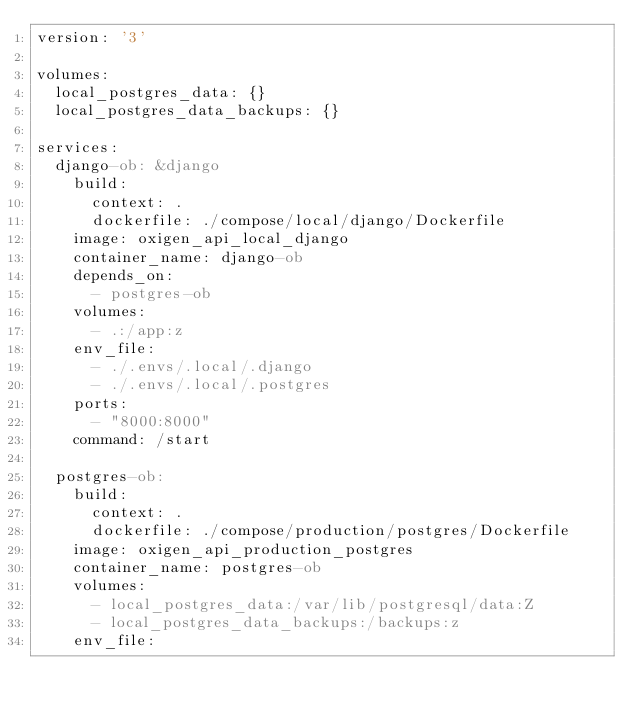Convert code to text. <code><loc_0><loc_0><loc_500><loc_500><_YAML_>version: '3'

volumes:
  local_postgres_data: {}
  local_postgres_data_backups: {}

services:
  django-ob: &django
    build:
      context: .
      dockerfile: ./compose/local/django/Dockerfile
    image: oxigen_api_local_django
    container_name: django-ob
    depends_on:
      - postgres-ob
    volumes:
      - .:/app:z
    env_file:
      - ./.envs/.local/.django
      - ./.envs/.local/.postgres
    ports:
      - "8000:8000"
    command: /start

  postgres-ob:
    build:
      context: .
      dockerfile: ./compose/production/postgres/Dockerfile
    image: oxigen_api_production_postgres
    container_name: postgres-ob
    volumes:
      - local_postgres_data:/var/lib/postgresql/data:Z
      - local_postgres_data_backups:/backups:z
    env_file:</code> 